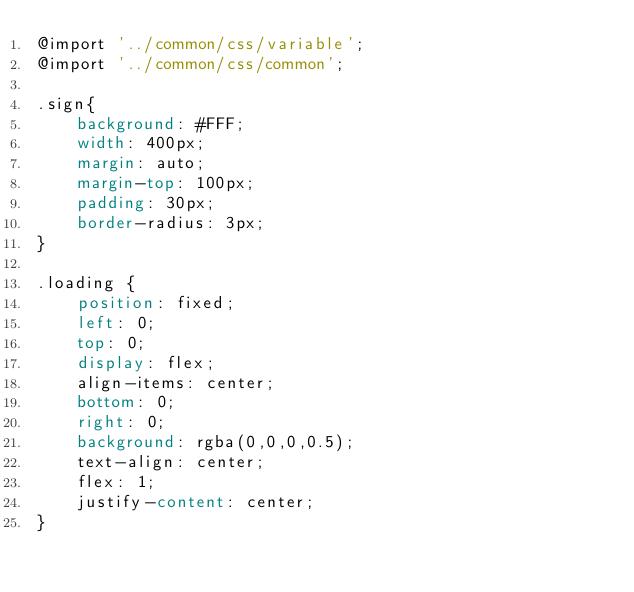Convert code to text. <code><loc_0><loc_0><loc_500><loc_500><_CSS_>@import '../common/css/variable';
@import '../common/css/common';

.sign{
    background: #FFF;
    width: 400px;
    margin: auto;
    margin-top: 100px;
    padding: 30px;
    border-radius: 3px;
}

.loading {
    position: fixed;
    left: 0;
    top: 0;
    display: flex;
    align-items: center;
    bottom: 0;
    right: 0;
    background: rgba(0,0,0,0.5);
    text-align: center;
    flex: 1;
    justify-content: center;
}</code> 